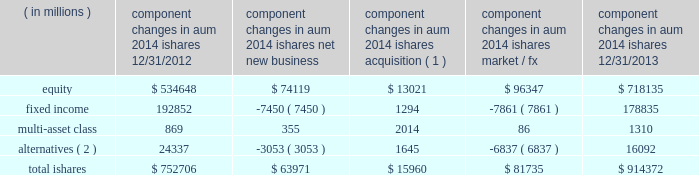The second largest closed-end fund manager and a top- ten manager by aum and 2013 net flows of long-term open-end mutual funds1 .
In 2013 , we were also the leading manager by net flows for long-dated fixed income mutual funds1 .
2022 we have fully integrated our legacy retail and ishares retail distribution teams to create a unified client-facing presence .
As retail clients increasingly use blackrock 2019s capabilities in combination 2014 active , alternative and passive 2014 it is a strategic priority for blackrock to coherently deliver these capabilities through one integrated team .
2022 international retail long-term net inflows of $ 17.5 billion , representing 15% ( 15 % ) organic growth , were positive across major regions and diversified across asset classes .
Equity net inflows of $ 6.4 billion were driven by strong demand for our top-performing european equities franchise as investor risk appetite for the sector improved .
Multi-asset class and fixed income products each generated net inflows of $ 4.8 billion , as investors looked to manage duration and volatility in their portfolios .
In 2013 , we were ranked as the third largest cross border fund provider2 .
In the united kingdom , we ranked among the five largest fund managers2 .
Ishares .
Alternatives ( 2 ) 24337 ( 3053 ) 1645 ( 6837 ) 16092 total ishares $ 752706 $ 63971 $ 15960 $ 81735 $ 914372 ( 1 ) amounts represent $ 16.0 billion of aum acquired in the credit suisse etf acquisition in july 2013 .
( 2 ) amounts include commodity ishares .
Ishares is the leading etf provider in the world , with $ 914.4 billion of aum at december 31 , 2013 , and was the top asset gatherer globally in 20133 with $ 64.0 billion of net inflows for an organic growth rate of 8% ( 8 % ) .
Equity net inflows of $ 74.1 billion were driven by flows into funds with broad developed market exposures , partially offset by outflows from emerging markets products .
Ishares fixed income experienced net outflows of $ 7.5 billion , as the continued low interest rate environment led many liquidity-oriented investors to sell long-duration assets , which made up the majority of the ishares fixed income suite .
In 2013 , we launched several funds to meet demand from clients seeking protection in a rising interest rate environment by offering an expanded product set that includes four new u.s .
Funds , including short-duration versions of our flagship high yield and investment grade credit products , and short maturity and liquidity income funds .
Ishares alternatives had $ 3.1 billion of net outflows predominantly out of commodities .
Ishares represented 23% ( 23 % ) of long-term aum at december 31 , 2013 and 35% ( 35 % ) of long-term base fees for ishares offers the most diverse product set in the industry with 703 etfs at year-end 2013 , and serves the broadest client base , covering more than 25 countries on five continents .
During 2013 , ishares continued its dual commitment to innovation and responsible product structuring by introducing 42 new etfs , acquiring credit suisse 2019s 58 etfs in europe and entering into a critical new strategic alliance with fidelity investments to deliver fidelity 2019s more than 10 million clients increased access to ishares products , tools and support .
Our alliance with fidelity investments and a successful full first year for the core series have deeply expanded our presence and offerings among buy-and-hold investors .
Our broad product range offers investors a precise , transparent and low-cost way to tap market returns and gain access to a full range of asset classes and global markets that have been difficult or expensive for many investors to access until now , as well as the liquidity required to make adjustments to their exposures quickly and cost-efficiently .
2022 u.s .
Ishares aum ended at $ 655.6 billion with $ 41.4 billion of net inflows driven by strong demand for developed markets equities and short-duration fixed income .
During the fourth quarter of 2012 , we debuted the core series in the united states , designed to provide the essential building blocks for buy-and-hold investors to use in constructing the core of their portfolio .
The core series demonstrated solid results in its first full year , raising $ 20.0 billion in net inflows , primarily in u.s .
Equities .
In the united states , ishares maintained its position as the largest etf provider , with 39% ( 39 % ) share of aum3 .
2022 international ishares aum ended at $ 258.8 billion with robust net new business of $ 22.6 billion led by demand for european and japanese equities , as well as a diverse range of fixed income products .
At year-end 2013 , ishares was the largest european etf provider with 48% ( 48 % ) of aum3 .
1 simfund 2 lipper feri 3 blackrock ; bloomberg .
What is the percentage change in the balance of total ishares in 2013 compare to 2012? 
Computations: ((914372 - 752706) / 752706)
Answer: 0.21478. 